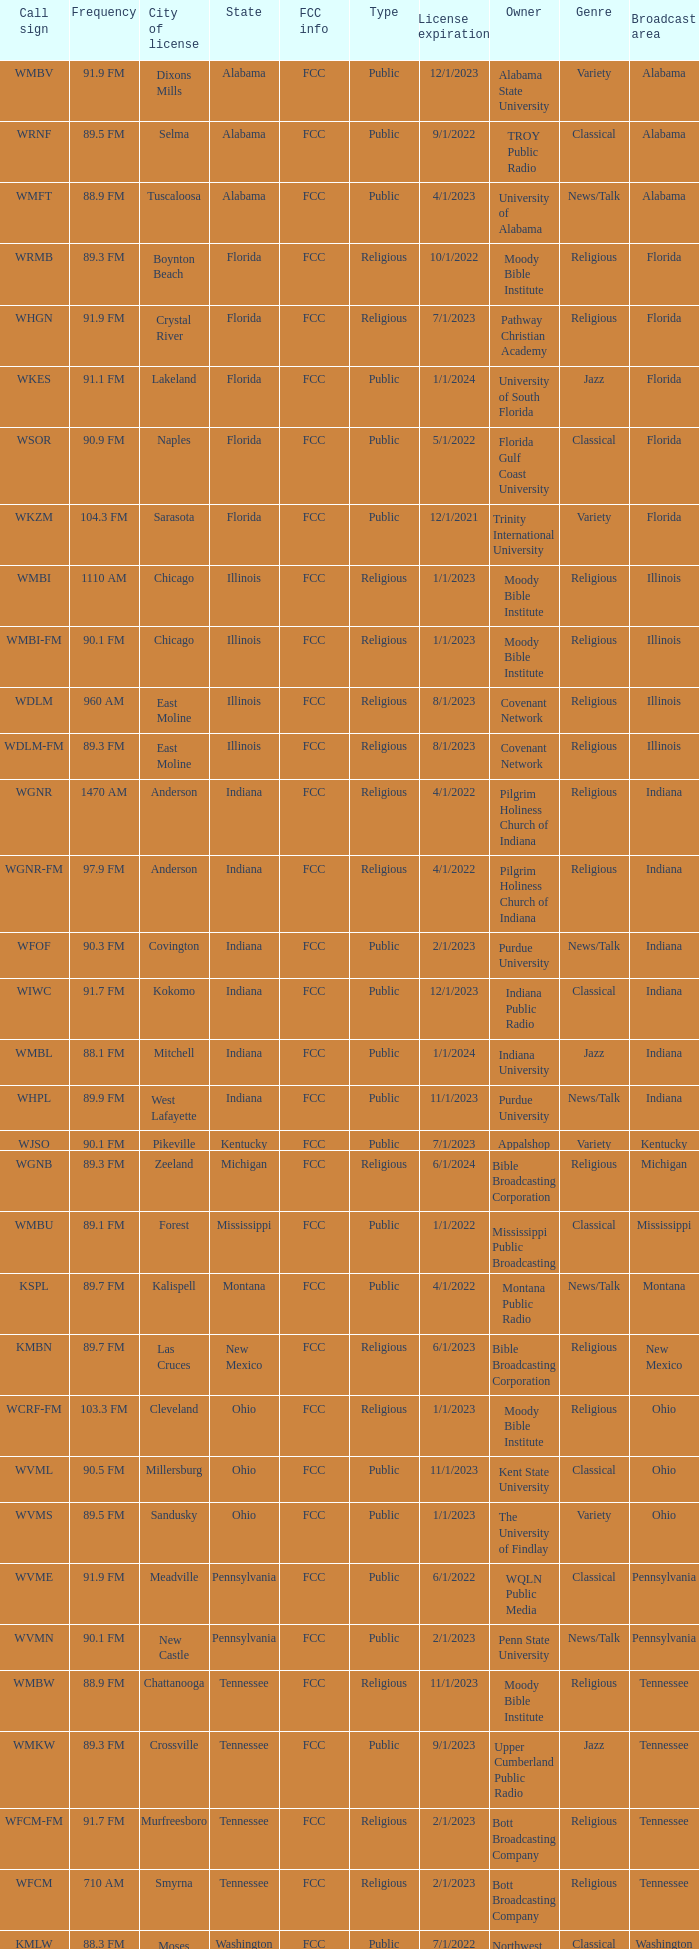What is the FCC info for the radio station in West Lafayette, Indiana? FCC. 